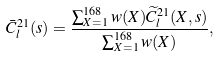Convert formula to latex. <formula><loc_0><loc_0><loc_500><loc_500>\bar { C } ^ { 2 1 } _ { l } ( s ) = \frac { \sum _ { X = 1 } ^ { 1 6 8 } w ( X ) \widetilde { C } _ { l } ^ { 2 1 } ( X , s ) } { \sum _ { X = 1 } ^ { 1 6 8 } w ( X ) } ,</formula> 